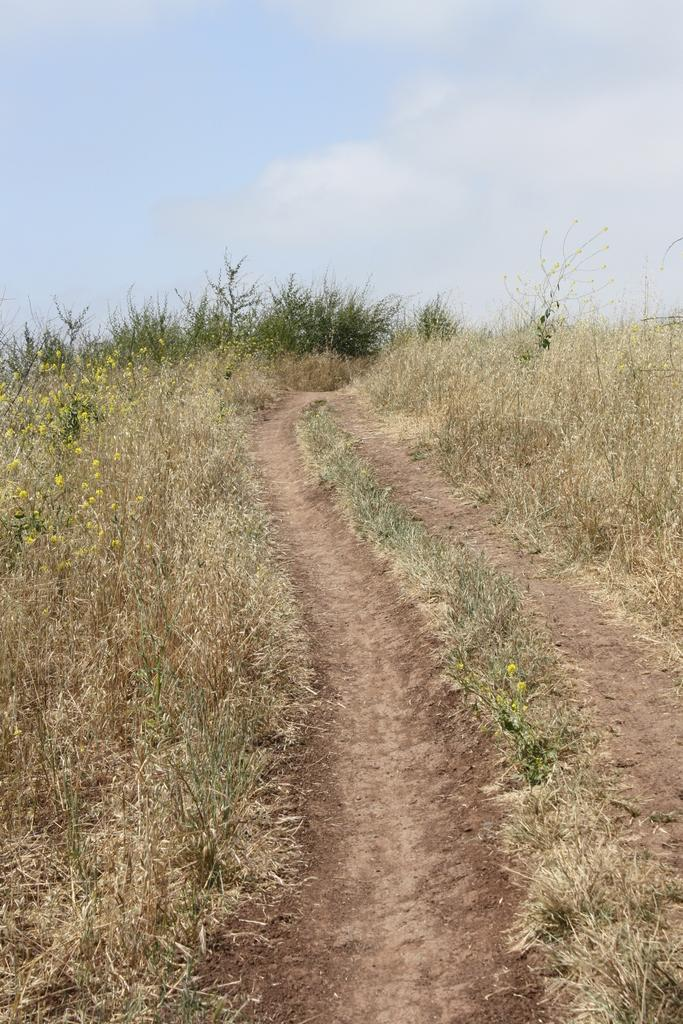What type of vegetation is visible in the image? There is grass in the image. What can be seen in the sky in the background of the image? There are clouds in the sky in the background of the image. What type of alarm can be heard going off in the image? There is no alarm present in the image, as it is a still image and cannot produce sound. 